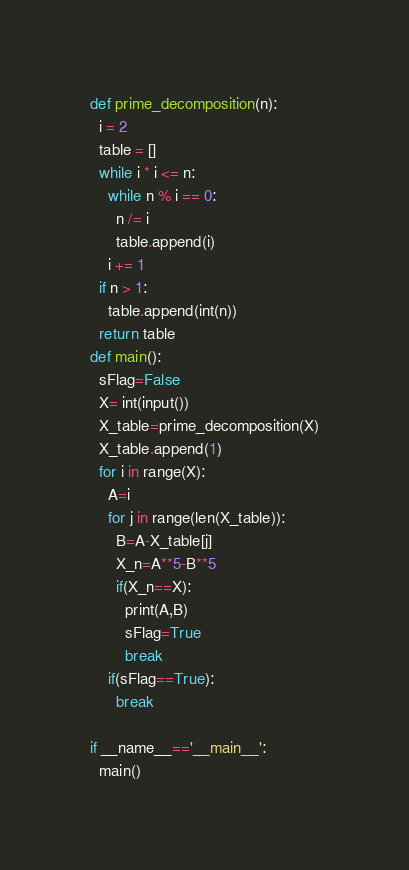<code> <loc_0><loc_0><loc_500><loc_500><_Python_>def prime_decomposition(n):
  i = 2
  table = []
  while i * i <= n:
    while n % i == 0:
      n /= i
      table.append(i)
    i += 1
  if n > 1:
    table.append(int(n))
  return table
def main():
  sFlag=False
  X= int(input())
  X_table=prime_decomposition(X)
  X_table.append(1)
  for i in range(X):
    A=i
    for j in range(len(X_table)):
      B=A-X_table[j]
      X_n=A**5-B**5
      if(X_n==X):
        print(A,B)
        sFlag=True
        break
    if(sFlag==True):
      break

if __name__=='__main__':
  main()</code> 